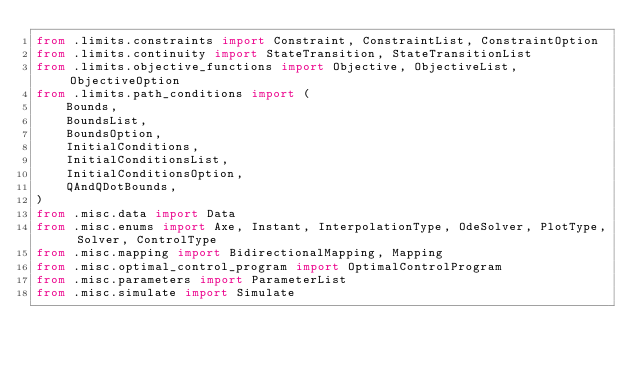<code> <loc_0><loc_0><loc_500><loc_500><_Python_>from .limits.constraints import Constraint, ConstraintList, ConstraintOption
from .limits.continuity import StateTransition, StateTransitionList
from .limits.objective_functions import Objective, ObjectiveList, ObjectiveOption
from .limits.path_conditions import (
    Bounds,
    BoundsList,
    BoundsOption,
    InitialConditions,
    InitialConditionsList,
    InitialConditionsOption,
    QAndQDotBounds,
)
from .misc.data import Data
from .misc.enums import Axe, Instant, InterpolationType, OdeSolver, PlotType, Solver, ControlType
from .misc.mapping import BidirectionalMapping, Mapping
from .misc.optimal_control_program import OptimalControlProgram
from .misc.parameters import ParameterList
from .misc.simulate import Simulate
</code> 